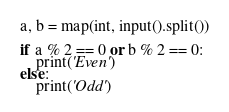<code> <loc_0><loc_0><loc_500><loc_500><_Python_>a, b = map(int, input().split())

if a % 2 == 0 or b % 2 == 0:
    print('Even')
else:
    print('Odd')</code> 